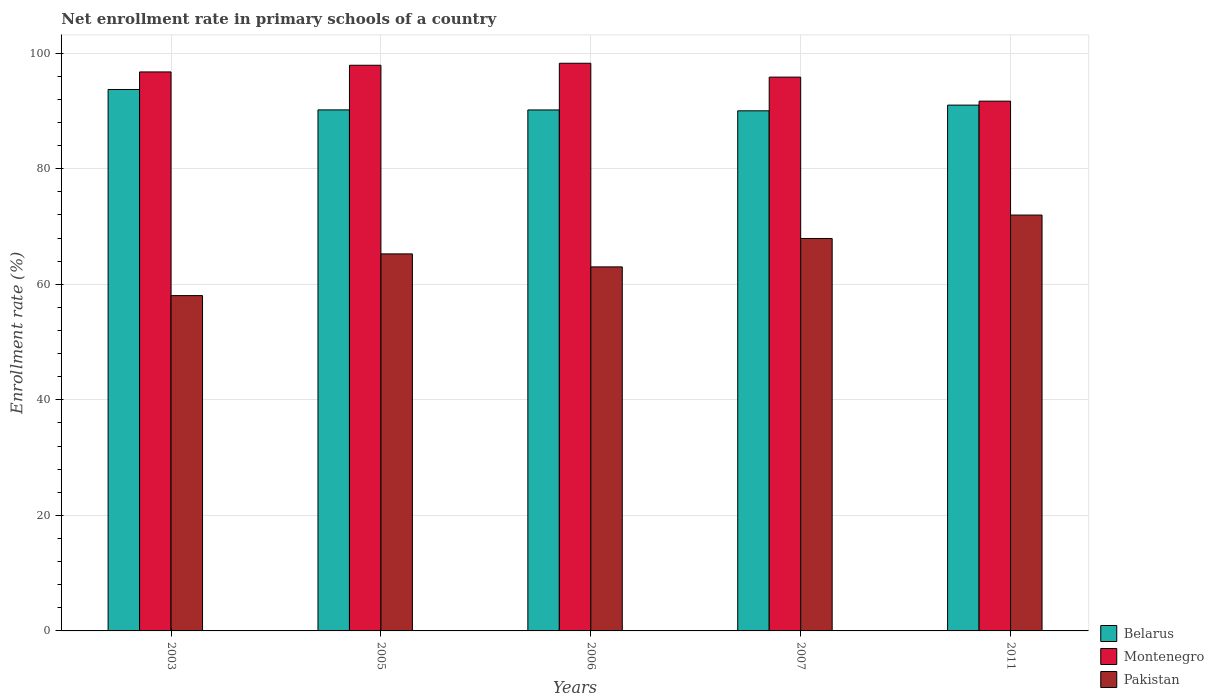How many groups of bars are there?
Offer a very short reply. 5. Are the number of bars on each tick of the X-axis equal?
Provide a short and direct response. Yes. How many bars are there on the 3rd tick from the left?
Your answer should be compact. 3. How many bars are there on the 3rd tick from the right?
Your answer should be very brief. 3. In how many cases, is the number of bars for a given year not equal to the number of legend labels?
Give a very brief answer. 0. What is the enrollment rate in primary schools in Montenegro in 2005?
Ensure brevity in your answer.  97.92. Across all years, what is the maximum enrollment rate in primary schools in Pakistan?
Your answer should be compact. 71.98. Across all years, what is the minimum enrollment rate in primary schools in Belarus?
Your answer should be compact. 90.03. What is the total enrollment rate in primary schools in Montenegro in the graph?
Provide a short and direct response. 480.51. What is the difference between the enrollment rate in primary schools in Belarus in 2006 and that in 2007?
Provide a short and direct response. 0.15. What is the difference between the enrollment rate in primary schools in Belarus in 2005 and the enrollment rate in primary schools in Pakistan in 2006?
Offer a very short reply. 27.18. What is the average enrollment rate in primary schools in Pakistan per year?
Your response must be concise. 65.25. In the year 2007, what is the difference between the enrollment rate in primary schools in Belarus and enrollment rate in primary schools in Montenegro?
Offer a very short reply. -5.83. What is the ratio of the enrollment rate in primary schools in Belarus in 2005 to that in 2007?
Provide a succinct answer. 1. Is the enrollment rate in primary schools in Belarus in 2005 less than that in 2007?
Give a very brief answer. No. Is the difference between the enrollment rate in primary schools in Belarus in 2005 and 2006 greater than the difference between the enrollment rate in primary schools in Montenegro in 2005 and 2006?
Your answer should be very brief. Yes. What is the difference between the highest and the second highest enrollment rate in primary schools in Pakistan?
Make the answer very short. 4.05. What is the difference between the highest and the lowest enrollment rate in primary schools in Montenegro?
Make the answer very short. 6.56. In how many years, is the enrollment rate in primary schools in Pakistan greater than the average enrollment rate in primary schools in Pakistan taken over all years?
Give a very brief answer. 3. Is the sum of the enrollment rate in primary schools in Montenegro in 2005 and 2006 greater than the maximum enrollment rate in primary schools in Pakistan across all years?
Provide a short and direct response. Yes. What does the 2nd bar from the left in 2003 represents?
Ensure brevity in your answer.  Montenegro. What does the 3rd bar from the right in 2005 represents?
Offer a very short reply. Belarus. How many years are there in the graph?
Keep it short and to the point. 5. What is the difference between two consecutive major ticks on the Y-axis?
Offer a terse response. 20. Are the values on the major ticks of Y-axis written in scientific E-notation?
Keep it short and to the point. No. Does the graph contain any zero values?
Ensure brevity in your answer.  No. Does the graph contain grids?
Make the answer very short. Yes. How are the legend labels stacked?
Offer a terse response. Vertical. What is the title of the graph?
Provide a succinct answer. Net enrollment rate in primary schools of a country. Does "Lower middle income" appear as one of the legend labels in the graph?
Keep it short and to the point. No. What is the label or title of the Y-axis?
Your answer should be compact. Enrollment rate (%). What is the Enrollment rate (%) in Belarus in 2003?
Offer a terse response. 93.72. What is the Enrollment rate (%) in Montenegro in 2003?
Provide a short and direct response. 96.76. What is the Enrollment rate (%) in Pakistan in 2003?
Your answer should be very brief. 58.04. What is the Enrollment rate (%) in Belarus in 2005?
Ensure brevity in your answer.  90.19. What is the Enrollment rate (%) of Montenegro in 2005?
Ensure brevity in your answer.  97.92. What is the Enrollment rate (%) of Pakistan in 2005?
Offer a terse response. 65.26. What is the Enrollment rate (%) in Belarus in 2006?
Ensure brevity in your answer.  90.18. What is the Enrollment rate (%) of Montenegro in 2006?
Make the answer very short. 98.26. What is the Enrollment rate (%) in Pakistan in 2006?
Make the answer very short. 63.01. What is the Enrollment rate (%) of Belarus in 2007?
Keep it short and to the point. 90.03. What is the Enrollment rate (%) in Montenegro in 2007?
Provide a succinct answer. 95.86. What is the Enrollment rate (%) in Pakistan in 2007?
Provide a short and direct response. 67.93. What is the Enrollment rate (%) in Belarus in 2011?
Provide a succinct answer. 91.02. What is the Enrollment rate (%) of Montenegro in 2011?
Offer a very short reply. 91.7. What is the Enrollment rate (%) in Pakistan in 2011?
Your answer should be very brief. 71.98. Across all years, what is the maximum Enrollment rate (%) in Belarus?
Ensure brevity in your answer.  93.72. Across all years, what is the maximum Enrollment rate (%) in Montenegro?
Keep it short and to the point. 98.26. Across all years, what is the maximum Enrollment rate (%) in Pakistan?
Make the answer very short. 71.98. Across all years, what is the minimum Enrollment rate (%) of Belarus?
Your response must be concise. 90.03. Across all years, what is the minimum Enrollment rate (%) in Montenegro?
Your answer should be compact. 91.7. Across all years, what is the minimum Enrollment rate (%) of Pakistan?
Your answer should be very brief. 58.04. What is the total Enrollment rate (%) of Belarus in the graph?
Provide a short and direct response. 455.14. What is the total Enrollment rate (%) of Montenegro in the graph?
Keep it short and to the point. 480.51. What is the total Enrollment rate (%) in Pakistan in the graph?
Provide a short and direct response. 326.24. What is the difference between the Enrollment rate (%) of Belarus in 2003 and that in 2005?
Give a very brief answer. 3.53. What is the difference between the Enrollment rate (%) in Montenegro in 2003 and that in 2005?
Provide a succinct answer. -1.15. What is the difference between the Enrollment rate (%) in Pakistan in 2003 and that in 2005?
Provide a short and direct response. -7.22. What is the difference between the Enrollment rate (%) in Belarus in 2003 and that in 2006?
Give a very brief answer. 3.54. What is the difference between the Enrollment rate (%) in Pakistan in 2003 and that in 2006?
Provide a succinct answer. -4.97. What is the difference between the Enrollment rate (%) of Belarus in 2003 and that in 2007?
Give a very brief answer. 3.69. What is the difference between the Enrollment rate (%) in Montenegro in 2003 and that in 2007?
Your answer should be compact. 0.9. What is the difference between the Enrollment rate (%) of Pakistan in 2003 and that in 2007?
Keep it short and to the point. -9.89. What is the difference between the Enrollment rate (%) in Belarus in 2003 and that in 2011?
Your answer should be very brief. 2.7. What is the difference between the Enrollment rate (%) in Montenegro in 2003 and that in 2011?
Provide a short and direct response. 5.06. What is the difference between the Enrollment rate (%) in Pakistan in 2003 and that in 2011?
Your response must be concise. -13.94. What is the difference between the Enrollment rate (%) of Belarus in 2005 and that in 2006?
Provide a short and direct response. 0.01. What is the difference between the Enrollment rate (%) in Montenegro in 2005 and that in 2006?
Your response must be concise. -0.35. What is the difference between the Enrollment rate (%) in Pakistan in 2005 and that in 2006?
Your response must be concise. 2.25. What is the difference between the Enrollment rate (%) in Belarus in 2005 and that in 2007?
Provide a short and direct response. 0.16. What is the difference between the Enrollment rate (%) of Montenegro in 2005 and that in 2007?
Provide a succinct answer. 2.05. What is the difference between the Enrollment rate (%) of Pakistan in 2005 and that in 2007?
Your response must be concise. -2.67. What is the difference between the Enrollment rate (%) of Belarus in 2005 and that in 2011?
Offer a very short reply. -0.83. What is the difference between the Enrollment rate (%) of Montenegro in 2005 and that in 2011?
Your answer should be compact. 6.21. What is the difference between the Enrollment rate (%) of Pakistan in 2005 and that in 2011?
Provide a succinct answer. -6.72. What is the difference between the Enrollment rate (%) of Belarus in 2006 and that in 2007?
Offer a very short reply. 0.15. What is the difference between the Enrollment rate (%) of Montenegro in 2006 and that in 2007?
Provide a succinct answer. 2.4. What is the difference between the Enrollment rate (%) of Pakistan in 2006 and that in 2007?
Provide a succinct answer. -4.92. What is the difference between the Enrollment rate (%) in Belarus in 2006 and that in 2011?
Provide a succinct answer. -0.84. What is the difference between the Enrollment rate (%) of Montenegro in 2006 and that in 2011?
Offer a terse response. 6.56. What is the difference between the Enrollment rate (%) in Pakistan in 2006 and that in 2011?
Offer a very short reply. -8.97. What is the difference between the Enrollment rate (%) in Belarus in 2007 and that in 2011?
Offer a terse response. -0.99. What is the difference between the Enrollment rate (%) of Montenegro in 2007 and that in 2011?
Provide a succinct answer. 4.16. What is the difference between the Enrollment rate (%) in Pakistan in 2007 and that in 2011?
Make the answer very short. -4.05. What is the difference between the Enrollment rate (%) in Belarus in 2003 and the Enrollment rate (%) in Montenegro in 2005?
Make the answer very short. -4.2. What is the difference between the Enrollment rate (%) of Belarus in 2003 and the Enrollment rate (%) of Pakistan in 2005?
Provide a short and direct response. 28.46. What is the difference between the Enrollment rate (%) in Montenegro in 2003 and the Enrollment rate (%) in Pakistan in 2005?
Your answer should be compact. 31.5. What is the difference between the Enrollment rate (%) in Belarus in 2003 and the Enrollment rate (%) in Montenegro in 2006?
Your answer should be compact. -4.54. What is the difference between the Enrollment rate (%) of Belarus in 2003 and the Enrollment rate (%) of Pakistan in 2006?
Your answer should be compact. 30.71. What is the difference between the Enrollment rate (%) in Montenegro in 2003 and the Enrollment rate (%) in Pakistan in 2006?
Your answer should be very brief. 33.75. What is the difference between the Enrollment rate (%) in Belarus in 2003 and the Enrollment rate (%) in Montenegro in 2007?
Your response must be concise. -2.14. What is the difference between the Enrollment rate (%) in Belarus in 2003 and the Enrollment rate (%) in Pakistan in 2007?
Give a very brief answer. 25.79. What is the difference between the Enrollment rate (%) in Montenegro in 2003 and the Enrollment rate (%) in Pakistan in 2007?
Your answer should be very brief. 28.83. What is the difference between the Enrollment rate (%) in Belarus in 2003 and the Enrollment rate (%) in Montenegro in 2011?
Make the answer very short. 2.02. What is the difference between the Enrollment rate (%) of Belarus in 2003 and the Enrollment rate (%) of Pakistan in 2011?
Give a very brief answer. 21.74. What is the difference between the Enrollment rate (%) in Montenegro in 2003 and the Enrollment rate (%) in Pakistan in 2011?
Your answer should be compact. 24.78. What is the difference between the Enrollment rate (%) in Belarus in 2005 and the Enrollment rate (%) in Montenegro in 2006?
Your response must be concise. -8.07. What is the difference between the Enrollment rate (%) of Belarus in 2005 and the Enrollment rate (%) of Pakistan in 2006?
Ensure brevity in your answer.  27.18. What is the difference between the Enrollment rate (%) of Montenegro in 2005 and the Enrollment rate (%) of Pakistan in 2006?
Make the answer very short. 34.9. What is the difference between the Enrollment rate (%) of Belarus in 2005 and the Enrollment rate (%) of Montenegro in 2007?
Give a very brief answer. -5.67. What is the difference between the Enrollment rate (%) in Belarus in 2005 and the Enrollment rate (%) in Pakistan in 2007?
Give a very brief answer. 22.26. What is the difference between the Enrollment rate (%) of Montenegro in 2005 and the Enrollment rate (%) of Pakistan in 2007?
Ensure brevity in your answer.  29.99. What is the difference between the Enrollment rate (%) in Belarus in 2005 and the Enrollment rate (%) in Montenegro in 2011?
Your answer should be compact. -1.51. What is the difference between the Enrollment rate (%) of Belarus in 2005 and the Enrollment rate (%) of Pakistan in 2011?
Offer a terse response. 18.2. What is the difference between the Enrollment rate (%) of Montenegro in 2005 and the Enrollment rate (%) of Pakistan in 2011?
Give a very brief answer. 25.93. What is the difference between the Enrollment rate (%) of Belarus in 2006 and the Enrollment rate (%) of Montenegro in 2007?
Your answer should be very brief. -5.68. What is the difference between the Enrollment rate (%) in Belarus in 2006 and the Enrollment rate (%) in Pakistan in 2007?
Keep it short and to the point. 22.25. What is the difference between the Enrollment rate (%) in Montenegro in 2006 and the Enrollment rate (%) in Pakistan in 2007?
Your response must be concise. 30.33. What is the difference between the Enrollment rate (%) of Belarus in 2006 and the Enrollment rate (%) of Montenegro in 2011?
Provide a short and direct response. -1.52. What is the difference between the Enrollment rate (%) in Belarus in 2006 and the Enrollment rate (%) in Pakistan in 2011?
Your answer should be very brief. 18.2. What is the difference between the Enrollment rate (%) in Montenegro in 2006 and the Enrollment rate (%) in Pakistan in 2011?
Your response must be concise. 26.28. What is the difference between the Enrollment rate (%) in Belarus in 2007 and the Enrollment rate (%) in Montenegro in 2011?
Make the answer very short. -1.67. What is the difference between the Enrollment rate (%) in Belarus in 2007 and the Enrollment rate (%) in Pakistan in 2011?
Keep it short and to the point. 18.04. What is the difference between the Enrollment rate (%) in Montenegro in 2007 and the Enrollment rate (%) in Pakistan in 2011?
Your response must be concise. 23.88. What is the average Enrollment rate (%) of Belarus per year?
Offer a terse response. 91.03. What is the average Enrollment rate (%) in Montenegro per year?
Keep it short and to the point. 96.1. What is the average Enrollment rate (%) in Pakistan per year?
Keep it short and to the point. 65.25. In the year 2003, what is the difference between the Enrollment rate (%) of Belarus and Enrollment rate (%) of Montenegro?
Make the answer very short. -3.04. In the year 2003, what is the difference between the Enrollment rate (%) in Belarus and Enrollment rate (%) in Pakistan?
Give a very brief answer. 35.68. In the year 2003, what is the difference between the Enrollment rate (%) in Montenegro and Enrollment rate (%) in Pakistan?
Make the answer very short. 38.72. In the year 2005, what is the difference between the Enrollment rate (%) in Belarus and Enrollment rate (%) in Montenegro?
Provide a succinct answer. -7.73. In the year 2005, what is the difference between the Enrollment rate (%) of Belarus and Enrollment rate (%) of Pakistan?
Provide a short and direct response. 24.93. In the year 2005, what is the difference between the Enrollment rate (%) in Montenegro and Enrollment rate (%) in Pakistan?
Your answer should be very brief. 32.65. In the year 2006, what is the difference between the Enrollment rate (%) of Belarus and Enrollment rate (%) of Montenegro?
Make the answer very short. -8.08. In the year 2006, what is the difference between the Enrollment rate (%) in Belarus and Enrollment rate (%) in Pakistan?
Provide a short and direct response. 27.17. In the year 2006, what is the difference between the Enrollment rate (%) of Montenegro and Enrollment rate (%) of Pakistan?
Offer a very short reply. 35.25. In the year 2007, what is the difference between the Enrollment rate (%) of Belarus and Enrollment rate (%) of Montenegro?
Offer a terse response. -5.83. In the year 2007, what is the difference between the Enrollment rate (%) in Belarus and Enrollment rate (%) in Pakistan?
Your answer should be very brief. 22.1. In the year 2007, what is the difference between the Enrollment rate (%) of Montenegro and Enrollment rate (%) of Pakistan?
Offer a terse response. 27.93. In the year 2011, what is the difference between the Enrollment rate (%) of Belarus and Enrollment rate (%) of Montenegro?
Make the answer very short. -0.69. In the year 2011, what is the difference between the Enrollment rate (%) of Belarus and Enrollment rate (%) of Pakistan?
Give a very brief answer. 19.03. In the year 2011, what is the difference between the Enrollment rate (%) of Montenegro and Enrollment rate (%) of Pakistan?
Offer a terse response. 19.72. What is the ratio of the Enrollment rate (%) in Belarus in 2003 to that in 2005?
Keep it short and to the point. 1.04. What is the ratio of the Enrollment rate (%) of Pakistan in 2003 to that in 2005?
Your response must be concise. 0.89. What is the ratio of the Enrollment rate (%) in Belarus in 2003 to that in 2006?
Provide a succinct answer. 1.04. What is the ratio of the Enrollment rate (%) of Montenegro in 2003 to that in 2006?
Provide a short and direct response. 0.98. What is the ratio of the Enrollment rate (%) of Pakistan in 2003 to that in 2006?
Offer a very short reply. 0.92. What is the ratio of the Enrollment rate (%) of Belarus in 2003 to that in 2007?
Offer a terse response. 1.04. What is the ratio of the Enrollment rate (%) of Montenegro in 2003 to that in 2007?
Make the answer very short. 1.01. What is the ratio of the Enrollment rate (%) in Pakistan in 2003 to that in 2007?
Offer a terse response. 0.85. What is the ratio of the Enrollment rate (%) of Belarus in 2003 to that in 2011?
Give a very brief answer. 1.03. What is the ratio of the Enrollment rate (%) of Montenegro in 2003 to that in 2011?
Offer a terse response. 1.06. What is the ratio of the Enrollment rate (%) in Pakistan in 2003 to that in 2011?
Offer a very short reply. 0.81. What is the ratio of the Enrollment rate (%) in Pakistan in 2005 to that in 2006?
Your response must be concise. 1.04. What is the ratio of the Enrollment rate (%) of Montenegro in 2005 to that in 2007?
Your response must be concise. 1.02. What is the ratio of the Enrollment rate (%) of Pakistan in 2005 to that in 2007?
Your answer should be compact. 0.96. What is the ratio of the Enrollment rate (%) of Belarus in 2005 to that in 2011?
Offer a very short reply. 0.99. What is the ratio of the Enrollment rate (%) of Montenegro in 2005 to that in 2011?
Your response must be concise. 1.07. What is the ratio of the Enrollment rate (%) of Pakistan in 2005 to that in 2011?
Make the answer very short. 0.91. What is the ratio of the Enrollment rate (%) in Belarus in 2006 to that in 2007?
Offer a very short reply. 1. What is the ratio of the Enrollment rate (%) of Montenegro in 2006 to that in 2007?
Your answer should be compact. 1.02. What is the ratio of the Enrollment rate (%) of Pakistan in 2006 to that in 2007?
Your answer should be very brief. 0.93. What is the ratio of the Enrollment rate (%) of Montenegro in 2006 to that in 2011?
Give a very brief answer. 1.07. What is the ratio of the Enrollment rate (%) in Pakistan in 2006 to that in 2011?
Offer a very short reply. 0.88. What is the ratio of the Enrollment rate (%) of Belarus in 2007 to that in 2011?
Your response must be concise. 0.99. What is the ratio of the Enrollment rate (%) of Montenegro in 2007 to that in 2011?
Make the answer very short. 1.05. What is the ratio of the Enrollment rate (%) of Pakistan in 2007 to that in 2011?
Provide a short and direct response. 0.94. What is the difference between the highest and the second highest Enrollment rate (%) in Belarus?
Provide a short and direct response. 2.7. What is the difference between the highest and the second highest Enrollment rate (%) of Montenegro?
Provide a short and direct response. 0.35. What is the difference between the highest and the second highest Enrollment rate (%) in Pakistan?
Keep it short and to the point. 4.05. What is the difference between the highest and the lowest Enrollment rate (%) in Belarus?
Your answer should be very brief. 3.69. What is the difference between the highest and the lowest Enrollment rate (%) of Montenegro?
Your answer should be very brief. 6.56. What is the difference between the highest and the lowest Enrollment rate (%) of Pakistan?
Provide a short and direct response. 13.94. 